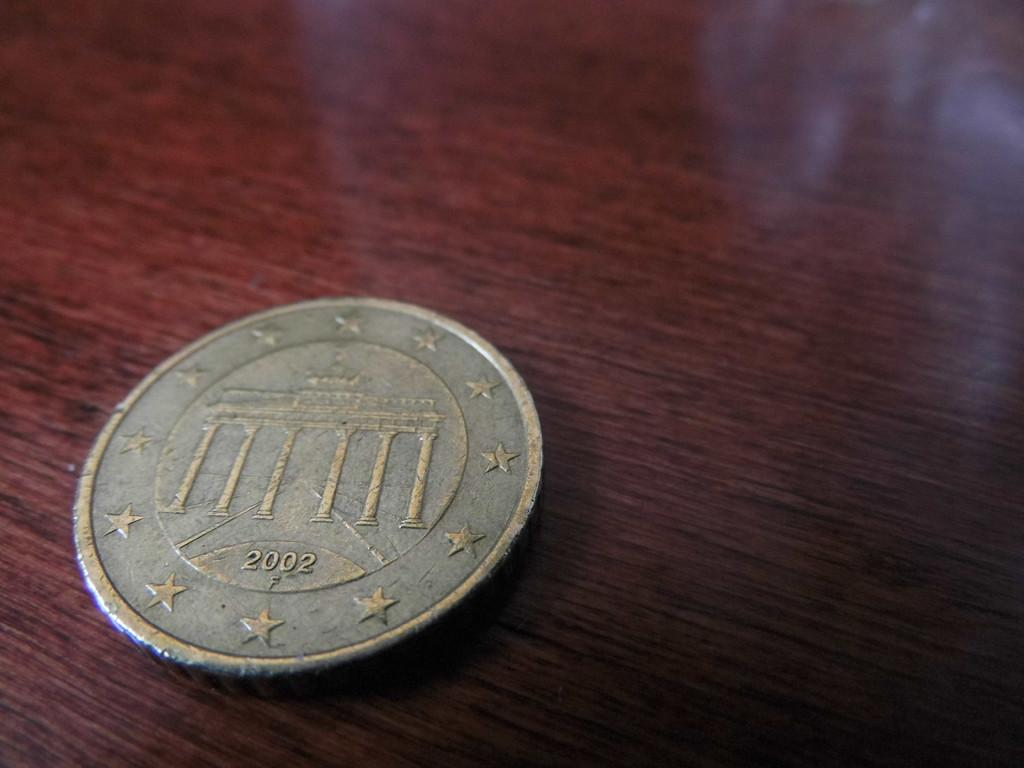<image>
Summarize the visual content of the image. A silver coin says 2002 and has stars around the edges. 